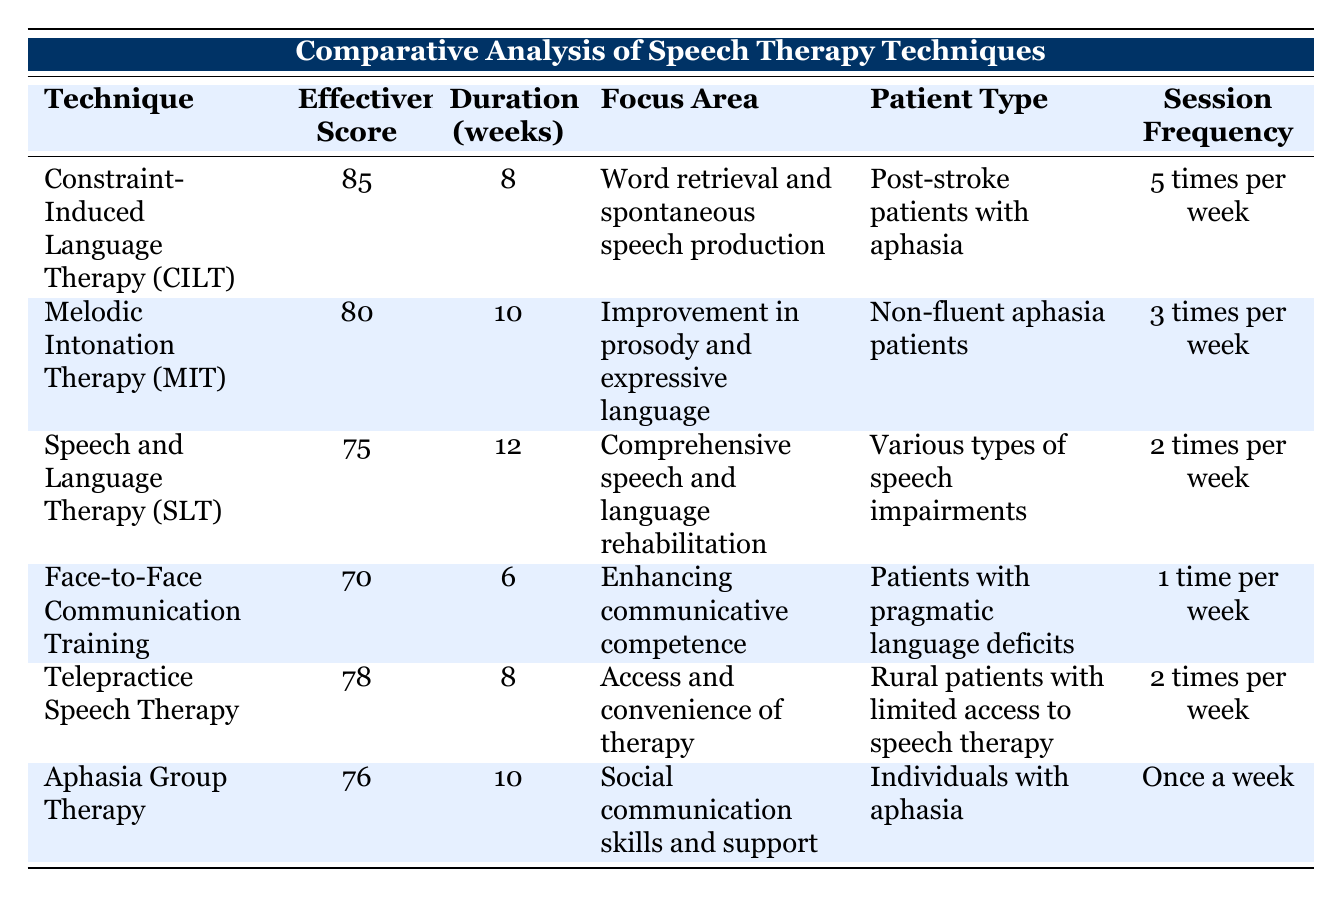What is the effectiveness score of Constraint-Induced Language Therapy (CILT)? The effectiveness score for CILT is directly listed in the table alongside the technique name, which is 85.
Answer: 85 What is the session frequency for Speech and Language Therapy (SLT)? The session frequency for SLT is provided in the table; it shows that SLT is conducted 2 times per week.
Answer: 2 times per week How many weeks does Melodic Intonation Therapy (MIT) last? The duration for MIT can be found in the table, and it states that MIT lasts for 10 weeks.
Answer: 10 Which therapy technique has the highest effectiveness score? By comparing all the effectiveness scores in the table, we can see that CILT has the highest score of 85, which is greater than all others listed.
Answer: Constraint-Induced Language Therapy (CILT) Is the effectiveness score of Telepractice Speech Therapy higher than that of Aphasia Group Therapy? The effectiveness score for Telepractice Speech Therapy is 78, while for Aphasia Group Therapy it is 76. Since 78 is greater than 76, the answer is yes.
Answer: Yes What is the average effectiveness score of all the listed speech therapy techniques? First, we sum the effectiveness scores: 85 + 80 + 75 + 70 + 78 + 76 = 464. Next, we divide by the number of techniques (6) to find the average: 464 / 6 = 77.33.
Answer: 77.33 Which technique focuses on improvement in prosody and expressive language? Looking at the focus area for each technique, MIT is the one that specifically states its focus is on improvement in prosody and expressive language.
Answer: Melodic Intonation Therapy (MIT) Are there any techniques that involve group therapy? The table mentions "Aphasia Group Therapy," which indicates that it is a form of group therapy aimed at individuals with aphasia. This confirms that there is indeed a technique focusing on group therapy.
Answer: Yes What is the duration difference between Face-to-Face Communication Training and Telepractice Speech Therapy? Face-to-Face Communication Training lasts 6 weeks while Telepractice Speech Therapy lasts 8 weeks. The difference is calculated by subtracting: 8 - 6 = 2 weeks.
Answer: 2 weeks Which technique has the lowest effectiveness score, and what is it? By examining all the effectiveness scores, Face-to-Face Communication Training has the lowest score, which is 70, making it the technique with the lowest effectiveness.
Answer: Face-to-Face Communication Training, 70 